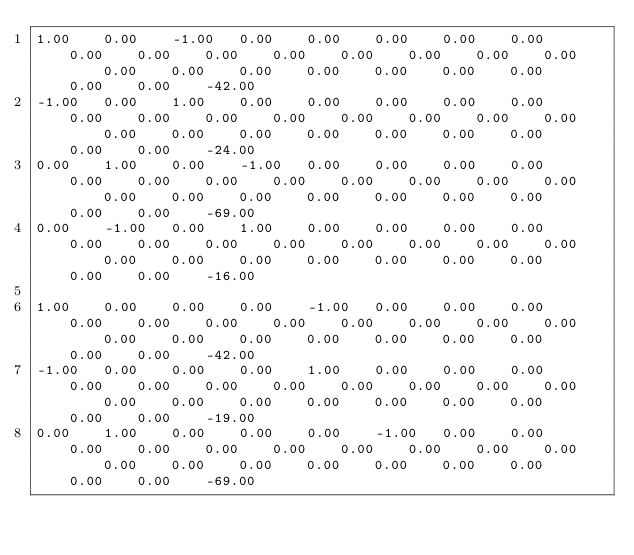<code> <loc_0><loc_0><loc_500><loc_500><_Matlab_>1.00	0.00	-1.00	0.00	0.00	0.00	0.00	0.00	0.00	0.00	0.00	0.00	0.00	0.00	0.00	0.00	0.00	0.00	0.00	0.00	0.00	0.00	0.00	0.00	0.00	-42.00
-1.00	0.00	1.00	0.00	0.00	0.00	0.00	0.00	0.00	0.00	0.00	0.00	0.00	0.00	0.00	0.00	0.00	0.00	0.00	0.00	0.00	0.00	0.00	0.00	0.00	-24.00
0.00	1.00	0.00	-1.00	0.00	0.00	0.00	0.00	0.00	0.00	0.00	0.00	0.00	0.00	0.00	0.00	0.00	0.00	0.00	0.00	0.00	0.00	0.00	0.00	0.00	-69.00
0.00	-1.00	0.00	1.00	0.00	0.00	0.00	0.00	0.00	0.00	0.00	0.00	0.00	0.00	0.00	0.00	0.00	0.00	0.00	0.00	0.00	0.00	0.00	0.00	0.00	-16.00

1.00	0.00	0.00	0.00	-1.00	0.00	0.00	0.00	0.00	0.00	0.00	0.00	0.00	0.00	0.00	0.00	0.00	0.00	0.00	0.00	0.00	0.00	0.00	0.00	0.00	-42.00
-1.00	0.00	0.00	0.00	1.00	0.00	0.00	0.00	0.00	0.00	0.00	0.00	0.00	0.00	0.00	0.00	0.00	0.00	0.00	0.00	0.00	0.00	0.00	0.00	0.00	-19.00
0.00	1.00	0.00	0.00	0.00	-1.00	0.00	0.00	0.00	0.00	0.00	0.00	0.00	0.00	0.00	0.00	0.00	0.00	0.00	0.00	0.00	0.00	0.00	0.00	0.00	-69.00</code> 